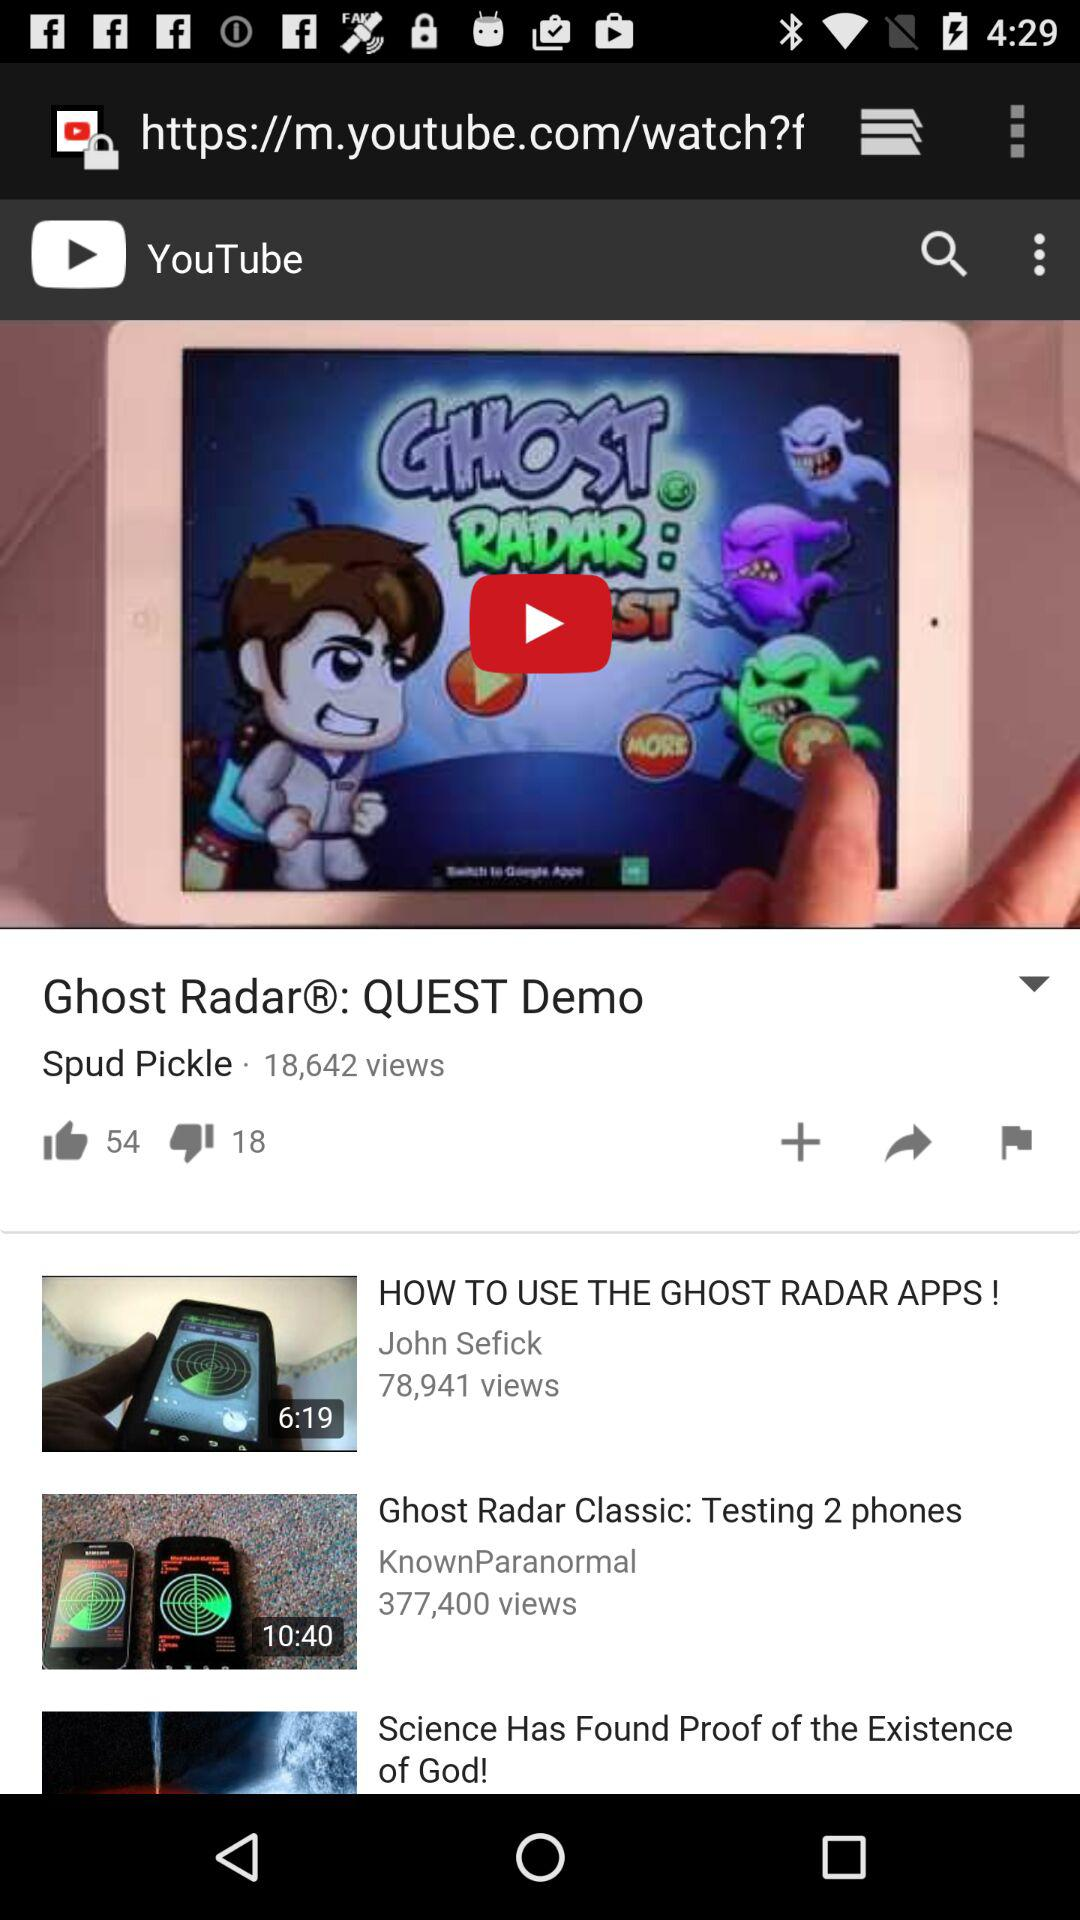What video has 18 dislikes? The video which has 18 dislikes is "Ghost Radar®: QUEST Demo". 